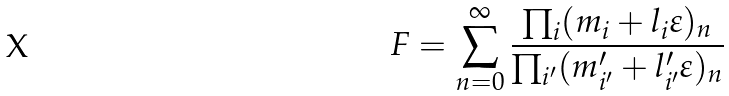Convert formula to latex. <formula><loc_0><loc_0><loc_500><loc_500>F = \sum _ { n = 0 } ^ { \infty } \frac { \prod _ { i } ( m _ { i } + l _ { i } \varepsilon ) _ { n } } { \prod _ { i ^ { \prime } } ( m ^ { \prime } _ { i ^ { \prime } } + l ^ { \prime } _ { i ^ { \prime } } \varepsilon ) _ { n } }</formula> 